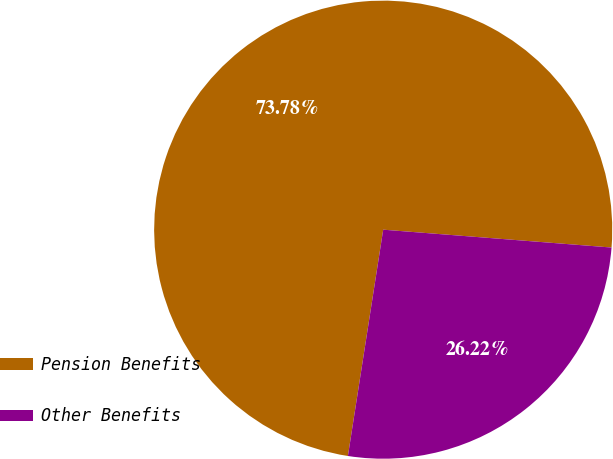Convert chart to OTSL. <chart><loc_0><loc_0><loc_500><loc_500><pie_chart><fcel>Pension Benefits<fcel>Other Benefits<nl><fcel>73.78%<fcel>26.22%<nl></chart> 